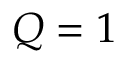Convert formula to latex. <formula><loc_0><loc_0><loc_500><loc_500>Q = 1</formula> 